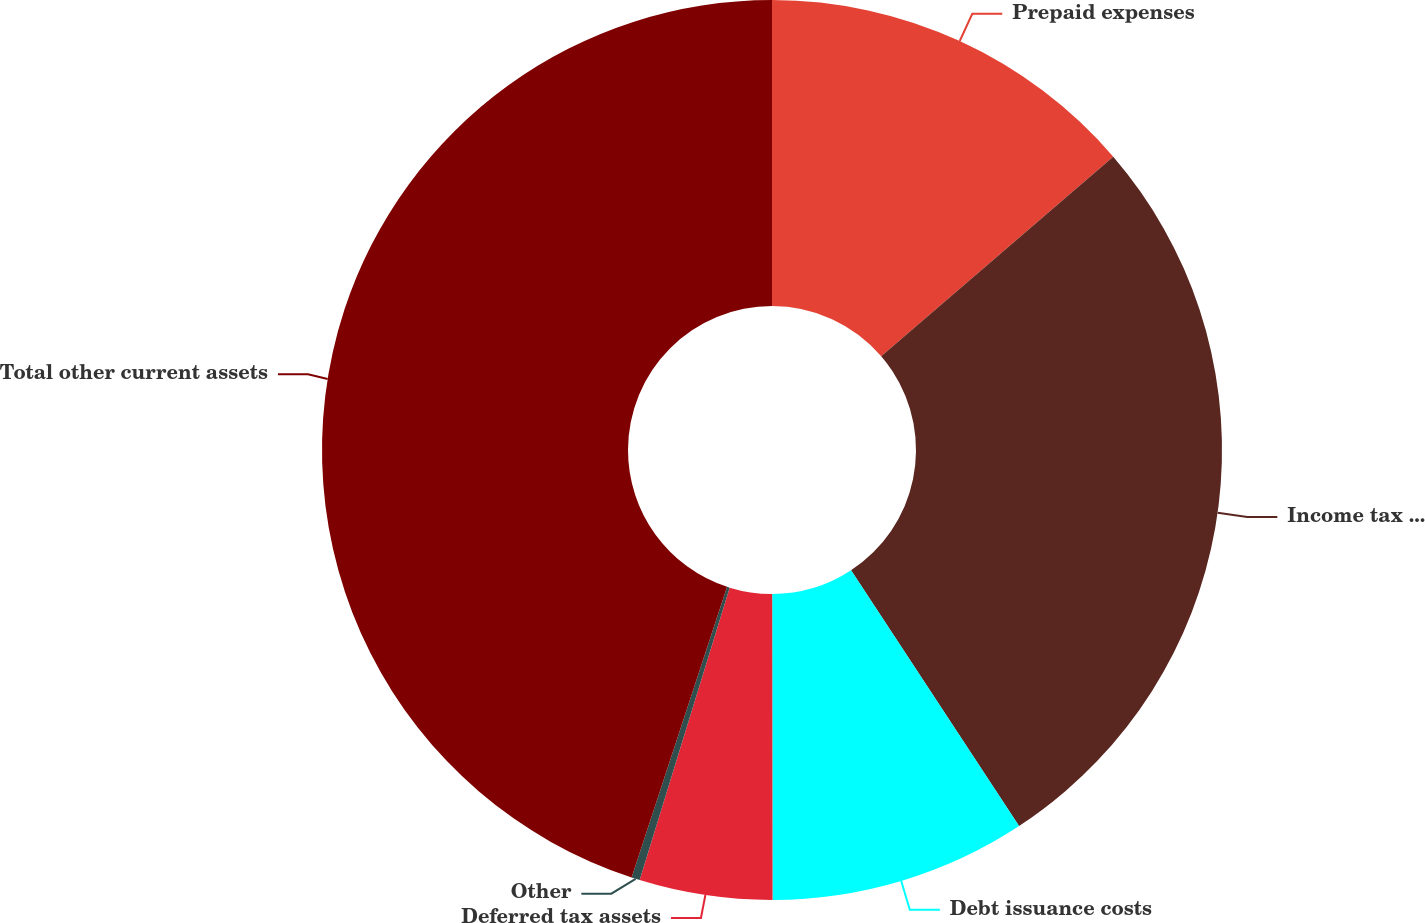<chart> <loc_0><loc_0><loc_500><loc_500><pie_chart><fcel>Prepaid expenses<fcel>Income tax and other<fcel>Debt issuance costs<fcel>Deferred tax assets<fcel>Other<fcel>Total other current assets<nl><fcel>13.7%<fcel>27.05%<fcel>9.23%<fcel>4.77%<fcel>0.3%<fcel>44.95%<nl></chart> 